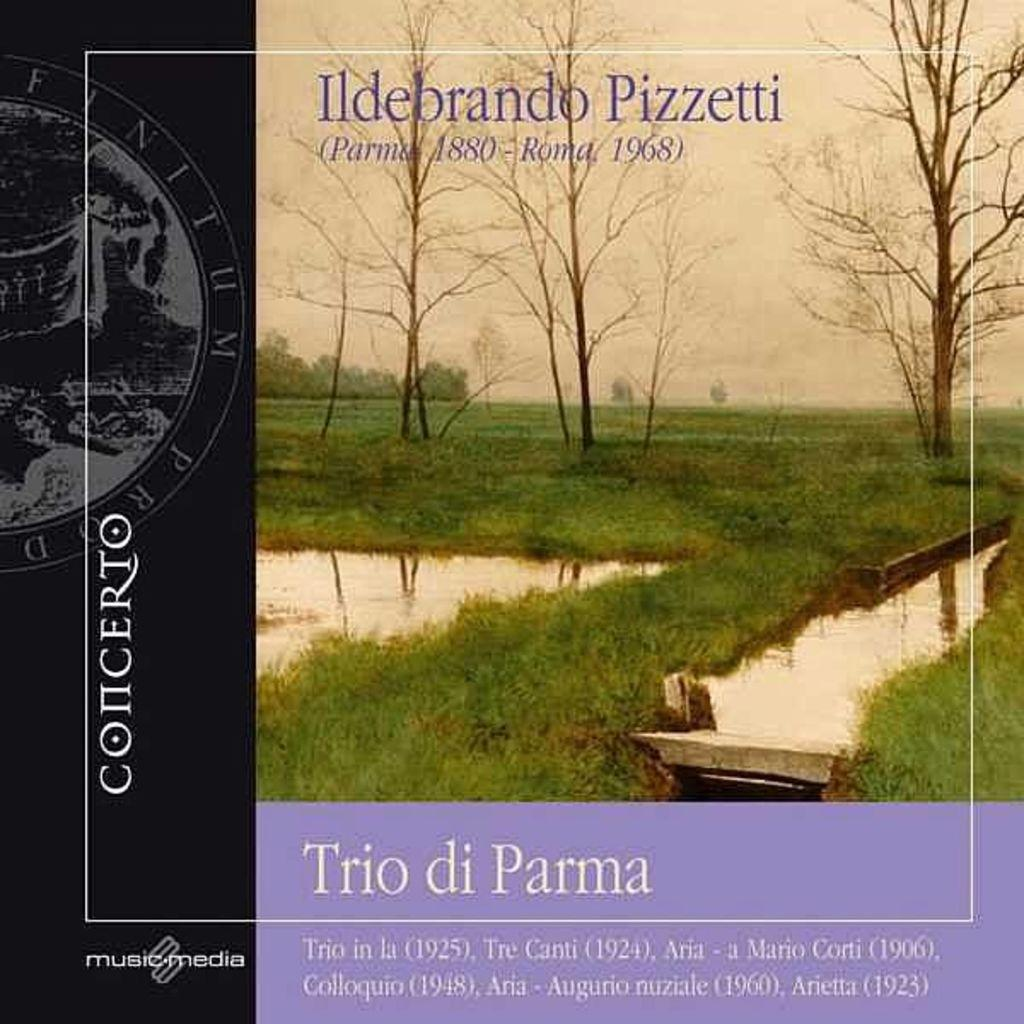What is the main subject of the image? The main subject of the image is a book cover. What natural elements are depicted on the book cover? The book cover has trees, grass, and water depicted on it. What part of the sky is visible on the book cover? The sky is visible at the top of the book cover. Are there any words or text on the book cover? Yes, there is text on the book cover. What type of force can be seen pushing the sticks in the image? There are no sticks present in the image; it features a book cover with trees, grass, water, and text. 